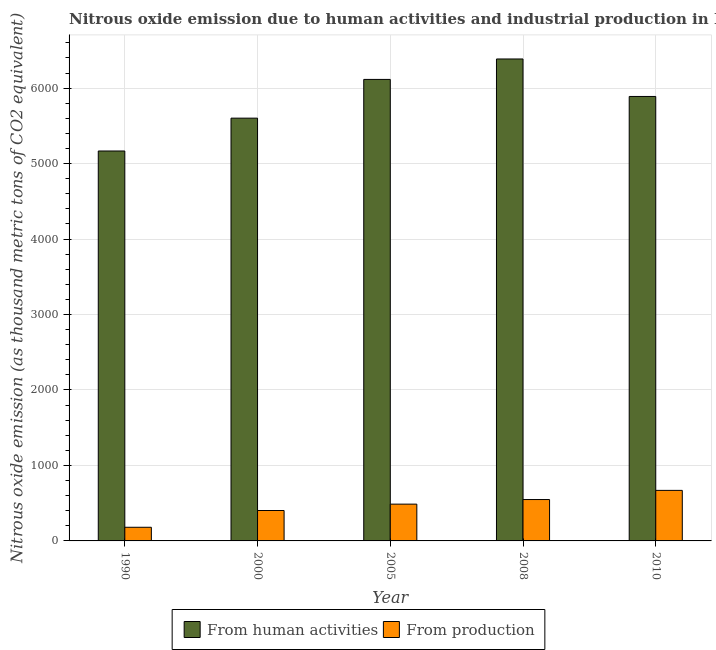How many different coloured bars are there?
Make the answer very short. 2. How many groups of bars are there?
Offer a terse response. 5. Are the number of bars per tick equal to the number of legend labels?
Your answer should be very brief. Yes. Are the number of bars on each tick of the X-axis equal?
Offer a terse response. Yes. How many bars are there on the 5th tick from the right?
Ensure brevity in your answer.  2. What is the amount of emissions generated from industries in 2005?
Make the answer very short. 487.4. Across all years, what is the maximum amount of emissions generated from industries?
Your answer should be very brief. 669.7. Across all years, what is the minimum amount of emissions from human activities?
Make the answer very short. 5166.9. What is the total amount of emissions generated from industries in the graph?
Your answer should be very brief. 2289.4. What is the difference between the amount of emissions generated from industries in 1990 and that in 2005?
Provide a succinct answer. -306.5. What is the difference between the amount of emissions from human activities in 2005 and the amount of emissions generated from industries in 2008?
Give a very brief answer. -270.8. What is the average amount of emissions from human activities per year?
Offer a very short reply. 5832. What is the ratio of the amount of emissions generated from industries in 2000 to that in 2008?
Ensure brevity in your answer.  0.74. Is the difference between the amount of emissions generated from industries in 2008 and 2010 greater than the difference between the amount of emissions from human activities in 2008 and 2010?
Your response must be concise. No. What is the difference between the highest and the second highest amount of emissions generated from industries?
Your answer should be compact. 121.4. What is the difference between the highest and the lowest amount of emissions generated from industries?
Offer a very short reply. 488.8. What does the 1st bar from the left in 2000 represents?
Provide a succinct answer. From human activities. What does the 2nd bar from the right in 1990 represents?
Make the answer very short. From human activities. How many bars are there?
Ensure brevity in your answer.  10. Are all the bars in the graph horizontal?
Give a very brief answer. No. How many years are there in the graph?
Ensure brevity in your answer.  5. Are the values on the major ticks of Y-axis written in scientific E-notation?
Give a very brief answer. No. Does the graph contain grids?
Offer a terse response. Yes. Where does the legend appear in the graph?
Provide a short and direct response. Bottom center. How many legend labels are there?
Provide a succinct answer. 2. What is the title of the graph?
Give a very brief answer. Nitrous oxide emission due to human activities and industrial production in Morocco. Does "Age 15+" appear as one of the legend labels in the graph?
Ensure brevity in your answer.  No. What is the label or title of the Y-axis?
Your answer should be very brief. Nitrous oxide emission (as thousand metric tons of CO2 equivalent). What is the Nitrous oxide emission (as thousand metric tons of CO2 equivalent) of From human activities in 1990?
Your answer should be very brief. 5166.9. What is the Nitrous oxide emission (as thousand metric tons of CO2 equivalent) of From production in 1990?
Your response must be concise. 180.9. What is the Nitrous oxide emission (as thousand metric tons of CO2 equivalent) in From human activities in 2000?
Make the answer very short. 5602. What is the Nitrous oxide emission (as thousand metric tons of CO2 equivalent) in From production in 2000?
Make the answer very short. 403.1. What is the Nitrous oxide emission (as thousand metric tons of CO2 equivalent) in From human activities in 2005?
Your answer should be compact. 6115.4. What is the Nitrous oxide emission (as thousand metric tons of CO2 equivalent) in From production in 2005?
Keep it short and to the point. 487.4. What is the Nitrous oxide emission (as thousand metric tons of CO2 equivalent) in From human activities in 2008?
Offer a very short reply. 6386.2. What is the Nitrous oxide emission (as thousand metric tons of CO2 equivalent) of From production in 2008?
Your response must be concise. 548.3. What is the Nitrous oxide emission (as thousand metric tons of CO2 equivalent) of From human activities in 2010?
Offer a very short reply. 5889.5. What is the Nitrous oxide emission (as thousand metric tons of CO2 equivalent) of From production in 2010?
Offer a very short reply. 669.7. Across all years, what is the maximum Nitrous oxide emission (as thousand metric tons of CO2 equivalent) of From human activities?
Keep it short and to the point. 6386.2. Across all years, what is the maximum Nitrous oxide emission (as thousand metric tons of CO2 equivalent) of From production?
Make the answer very short. 669.7. Across all years, what is the minimum Nitrous oxide emission (as thousand metric tons of CO2 equivalent) of From human activities?
Provide a short and direct response. 5166.9. Across all years, what is the minimum Nitrous oxide emission (as thousand metric tons of CO2 equivalent) of From production?
Your answer should be very brief. 180.9. What is the total Nitrous oxide emission (as thousand metric tons of CO2 equivalent) in From human activities in the graph?
Your response must be concise. 2.92e+04. What is the total Nitrous oxide emission (as thousand metric tons of CO2 equivalent) in From production in the graph?
Provide a short and direct response. 2289.4. What is the difference between the Nitrous oxide emission (as thousand metric tons of CO2 equivalent) in From human activities in 1990 and that in 2000?
Your answer should be very brief. -435.1. What is the difference between the Nitrous oxide emission (as thousand metric tons of CO2 equivalent) of From production in 1990 and that in 2000?
Provide a succinct answer. -222.2. What is the difference between the Nitrous oxide emission (as thousand metric tons of CO2 equivalent) in From human activities in 1990 and that in 2005?
Give a very brief answer. -948.5. What is the difference between the Nitrous oxide emission (as thousand metric tons of CO2 equivalent) of From production in 1990 and that in 2005?
Ensure brevity in your answer.  -306.5. What is the difference between the Nitrous oxide emission (as thousand metric tons of CO2 equivalent) of From human activities in 1990 and that in 2008?
Your answer should be very brief. -1219.3. What is the difference between the Nitrous oxide emission (as thousand metric tons of CO2 equivalent) of From production in 1990 and that in 2008?
Give a very brief answer. -367.4. What is the difference between the Nitrous oxide emission (as thousand metric tons of CO2 equivalent) of From human activities in 1990 and that in 2010?
Your response must be concise. -722.6. What is the difference between the Nitrous oxide emission (as thousand metric tons of CO2 equivalent) of From production in 1990 and that in 2010?
Your answer should be very brief. -488.8. What is the difference between the Nitrous oxide emission (as thousand metric tons of CO2 equivalent) of From human activities in 2000 and that in 2005?
Your response must be concise. -513.4. What is the difference between the Nitrous oxide emission (as thousand metric tons of CO2 equivalent) in From production in 2000 and that in 2005?
Your answer should be very brief. -84.3. What is the difference between the Nitrous oxide emission (as thousand metric tons of CO2 equivalent) in From human activities in 2000 and that in 2008?
Give a very brief answer. -784.2. What is the difference between the Nitrous oxide emission (as thousand metric tons of CO2 equivalent) of From production in 2000 and that in 2008?
Ensure brevity in your answer.  -145.2. What is the difference between the Nitrous oxide emission (as thousand metric tons of CO2 equivalent) in From human activities in 2000 and that in 2010?
Provide a succinct answer. -287.5. What is the difference between the Nitrous oxide emission (as thousand metric tons of CO2 equivalent) in From production in 2000 and that in 2010?
Your answer should be compact. -266.6. What is the difference between the Nitrous oxide emission (as thousand metric tons of CO2 equivalent) in From human activities in 2005 and that in 2008?
Make the answer very short. -270.8. What is the difference between the Nitrous oxide emission (as thousand metric tons of CO2 equivalent) in From production in 2005 and that in 2008?
Offer a very short reply. -60.9. What is the difference between the Nitrous oxide emission (as thousand metric tons of CO2 equivalent) in From human activities in 2005 and that in 2010?
Provide a succinct answer. 225.9. What is the difference between the Nitrous oxide emission (as thousand metric tons of CO2 equivalent) of From production in 2005 and that in 2010?
Provide a succinct answer. -182.3. What is the difference between the Nitrous oxide emission (as thousand metric tons of CO2 equivalent) of From human activities in 2008 and that in 2010?
Offer a very short reply. 496.7. What is the difference between the Nitrous oxide emission (as thousand metric tons of CO2 equivalent) in From production in 2008 and that in 2010?
Offer a very short reply. -121.4. What is the difference between the Nitrous oxide emission (as thousand metric tons of CO2 equivalent) of From human activities in 1990 and the Nitrous oxide emission (as thousand metric tons of CO2 equivalent) of From production in 2000?
Provide a succinct answer. 4763.8. What is the difference between the Nitrous oxide emission (as thousand metric tons of CO2 equivalent) in From human activities in 1990 and the Nitrous oxide emission (as thousand metric tons of CO2 equivalent) in From production in 2005?
Your answer should be very brief. 4679.5. What is the difference between the Nitrous oxide emission (as thousand metric tons of CO2 equivalent) in From human activities in 1990 and the Nitrous oxide emission (as thousand metric tons of CO2 equivalent) in From production in 2008?
Your answer should be compact. 4618.6. What is the difference between the Nitrous oxide emission (as thousand metric tons of CO2 equivalent) of From human activities in 1990 and the Nitrous oxide emission (as thousand metric tons of CO2 equivalent) of From production in 2010?
Ensure brevity in your answer.  4497.2. What is the difference between the Nitrous oxide emission (as thousand metric tons of CO2 equivalent) in From human activities in 2000 and the Nitrous oxide emission (as thousand metric tons of CO2 equivalent) in From production in 2005?
Your answer should be very brief. 5114.6. What is the difference between the Nitrous oxide emission (as thousand metric tons of CO2 equivalent) of From human activities in 2000 and the Nitrous oxide emission (as thousand metric tons of CO2 equivalent) of From production in 2008?
Keep it short and to the point. 5053.7. What is the difference between the Nitrous oxide emission (as thousand metric tons of CO2 equivalent) of From human activities in 2000 and the Nitrous oxide emission (as thousand metric tons of CO2 equivalent) of From production in 2010?
Make the answer very short. 4932.3. What is the difference between the Nitrous oxide emission (as thousand metric tons of CO2 equivalent) in From human activities in 2005 and the Nitrous oxide emission (as thousand metric tons of CO2 equivalent) in From production in 2008?
Give a very brief answer. 5567.1. What is the difference between the Nitrous oxide emission (as thousand metric tons of CO2 equivalent) of From human activities in 2005 and the Nitrous oxide emission (as thousand metric tons of CO2 equivalent) of From production in 2010?
Your response must be concise. 5445.7. What is the difference between the Nitrous oxide emission (as thousand metric tons of CO2 equivalent) in From human activities in 2008 and the Nitrous oxide emission (as thousand metric tons of CO2 equivalent) in From production in 2010?
Make the answer very short. 5716.5. What is the average Nitrous oxide emission (as thousand metric tons of CO2 equivalent) of From human activities per year?
Provide a short and direct response. 5832. What is the average Nitrous oxide emission (as thousand metric tons of CO2 equivalent) of From production per year?
Provide a short and direct response. 457.88. In the year 1990, what is the difference between the Nitrous oxide emission (as thousand metric tons of CO2 equivalent) of From human activities and Nitrous oxide emission (as thousand metric tons of CO2 equivalent) of From production?
Offer a very short reply. 4986. In the year 2000, what is the difference between the Nitrous oxide emission (as thousand metric tons of CO2 equivalent) of From human activities and Nitrous oxide emission (as thousand metric tons of CO2 equivalent) of From production?
Give a very brief answer. 5198.9. In the year 2005, what is the difference between the Nitrous oxide emission (as thousand metric tons of CO2 equivalent) of From human activities and Nitrous oxide emission (as thousand metric tons of CO2 equivalent) of From production?
Offer a very short reply. 5628. In the year 2008, what is the difference between the Nitrous oxide emission (as thousand metric tons of CO2 equivalent) in From human activities and Nitrous oxide emission (as thousand metric tons of CO2 equivalent) in From production?
Offer a terse response. 5837.9. In the year 2010, what is the difference between the Nitrous oxide emission (as thousand metric tons of CO2 equivalent) in From human activities and Nitrous oxide emission (as thousand metric tons of CO2 equivalent) in From production?
Offer a very short reply. 5219.8. What is the ratio of the Nitrous oxide emission (as thousand metric tons of CO2 equivalent) of From human activities in 1990 to that in 2000?
Ensure brevity in your answer.  0.92. What is the ratio of the Nitrous oxide emission (as thousand metric tons of CO2 equivalent) of From production in 1990 to that in 2000?
Your answer should be very brief. 0.45. What is the ratio of the Nitrous oxide emission (as thousand metric tons of CO2 equivalent) in From human activities in 1990 to that in 2005?
Offer a very short reply. 0.84. What is the ratio of the Nitrous oxide emission (as thousand metric tons of CO2 equivalent) in From production in 1990 to that in 2005?
Ensure brevity in your answer.  0.37. What is the ratio of the Nitrous oxide emission (as thousand metric tons of CO2 equivalent) of From human activities in 1990 to that in 2008?
Provide a succinct answer. 0.81. What is the ratio of the Nitrous oxide emission (as thousand metric tons of CO2 equivalent) in From production in 1990 to that in 2008?
Offer a very short reply. 0.33. What is the ratio of the Nitrous oxide emission (as thousand metric tons of CO2 equivalent) of From human activities in 1990 to that in 2010?
Give a very brief answer. 0.88. What is the ratio of the Nitrous oxide emission (as thousand metric tons of CO2 equivalent) in From production in 1990 to that in 2010?
Keep it short and to the point. 0.27. What is the ratio of the Nitrous oxide emission (as thousand metric tons of CO2 equivalent) in From human activities in 2000 to that in 2005?
Provide a short and direct response. 0.92. What is the ratio of the Nitrous oxide emission (as thousand metric tons of CO2 equivalent) in From production in 2000 to that in 2005?
Keep it short and to the point. 0.83. What is the ratio of the Nitrous oxide emission (as thousand metric tons of CO2 equivalent) in From human activities in 2000 to that in 2008?
Offer a terse response. 0.88. What is the ratio of the Nitrous oxide emission (as thousand metric tons of CO2 equivalent) in From production in 2000 to that in 2008?
Offer a terse response. 0.74. What is the ratio of the Nitrous oxide emission (as thousand metric tons of CO2 equivalent) in From human activities in 2000 to that in 2010?
Ensure brevity in your answer.  0.95. What is the ratio of the Nitrous oxide emission (as thousand metric tons of CO2 equivalent) of From production in 2000 to that in 2010?
Provide a short and direct response. 0.6. What is the ratio of the Nitrous oxide emission (as thousand metric tons of CO2 equivalent) of From human activities in 2005 to that in 2008?
Provide a short and direct response. 0.96. What is the ratio of the Nitrous oxide emission (as thousand metric tons of CO2 equivalent) in From production in 2005 to that in 2008?
Make the answer very short. 0.89. What is the ratio of the Nitrous oxide emission (as thousand metric tons of CO2 equivalent) in From human activities in 2005 to that in 2010?
Offer a very short reply. 1.04. What is the ratio of the Nitrous oxide emission (as thousand metric tons of CO2 equivalent) in From production in 2005 to that in 2010?
Your answer should be compact. 0.73. What is the ratio of the Nitrous oxide emission (as thousand metric tons of CO2 equivalent) in From human activities in 2008 to that in 2010?
Keep it short and to the point. 1.08. What is the ratio of the Nitrous oxide emission (as thousand metric tons of CO2 equivalent) in From production in 2008 to that in 2010?
Ensure brevity in your answer.  0.82. What is the difference between the highest and the second highest Nitrous oxide emission (as thousand metric tons of CO2 equivalent) of From human activities?
Offer a very short reply. 270.8. What is the difference between the highest and the second highest Nitrous oxide emission (as thousand metric tons of CO2 equivalent) in From production?
Provide a succinct answer. 121.4. What is the difference between the highest and the lowest Nitrous oxide emission (as thousand metric tons of CO2 equivalent) in From human activities?
Your answer should be very brief. 1219.3. What is the difference between the highest and the lowest Nitrous oxide emission (as thousand metric tons of CO2 equivalent) in From production?
Provide a succinct answer. 488.8. 